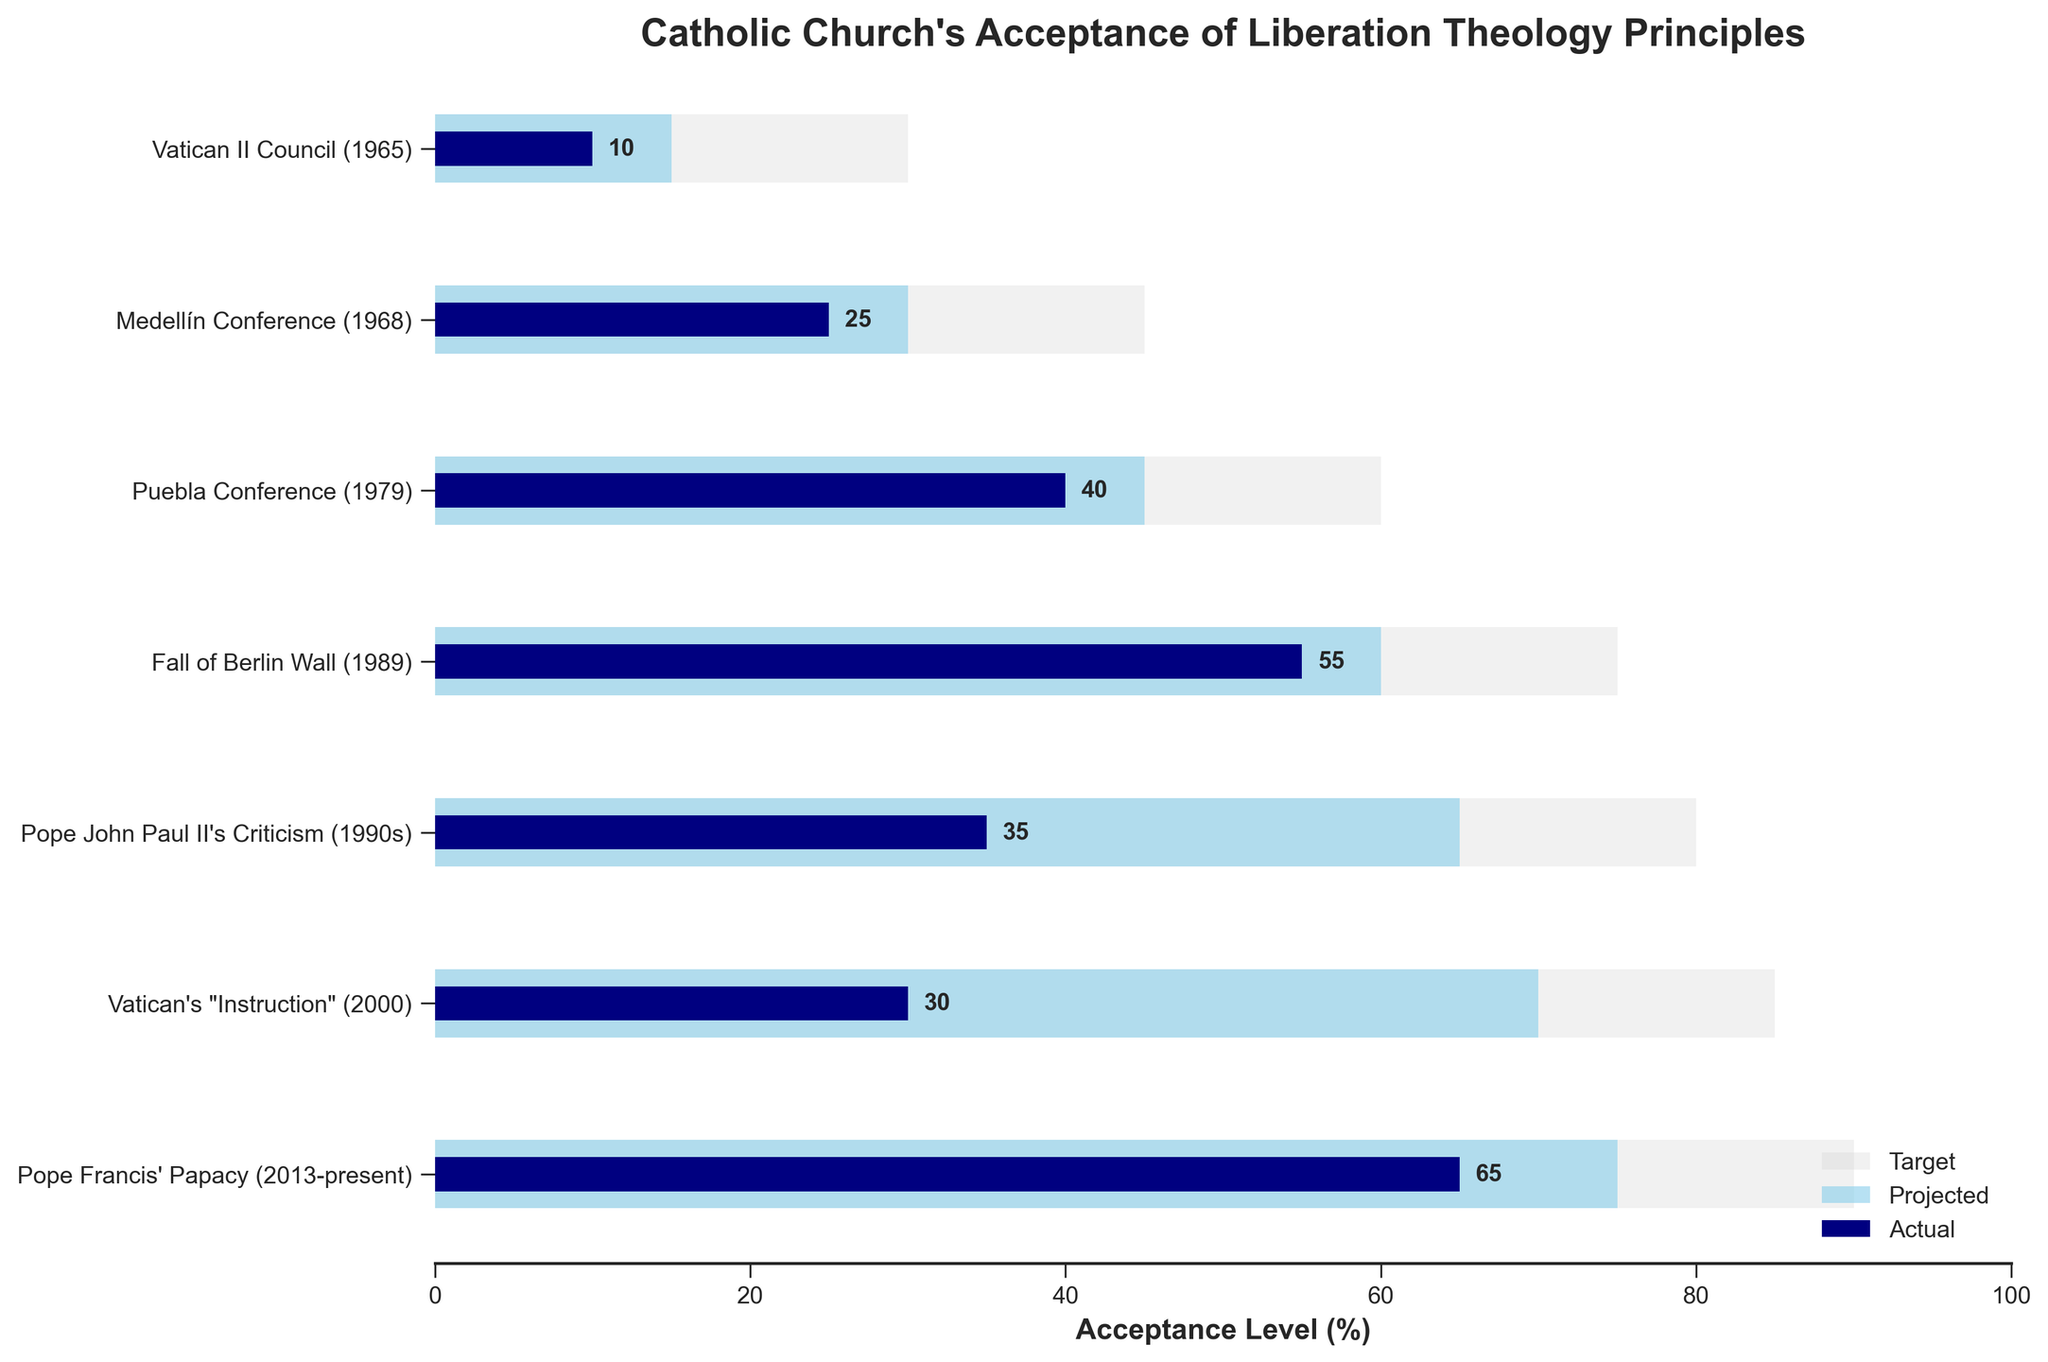What is the title of the chart? The title can be seen at the top of the figure. It is "Catholic Church's Acceptance of Liberation Theology Principles".
Answer: Catholic Church's Acceptance of Liberation Theology Principles How many data points are represented in the figure? By counting the categories on the y-axis, we can see there are 7 data points.
Answer: 7 Which historical event shows the highest actual acceptance of liberation theology principles? By looking at the actual acceptance bars, the longest is for "Pope Francis' Papacy (2013-present)" with a value of 65.
Answer: Pope Francis' Papacy (2013-present) What is the difference between the projected and actual acceptance levels for Pope Francis' Papacy? The projected acceptance for Pope Francis' Papacy is 75 and the actual acceptance is 65. The difference is 75 - 65.
Answer: 10 At which historical point did the actual acceptance level decrease following an initial increase? Observing the trends, the actual acceptance levels rise from "Vatican II Council" to "Fall of Berlin Wall", but then decrease at "Pope John Paul II's Criticism" and "Vatican's Instruction".
Answer: Pope John Paul II's Criticism What is the target acceptance level during the Vatican II Council (1965)? Looking at the target bar corresponding to "Vatican II Council (1965)", it reaches up to 30.
Answer: 30 Which historical event had the smallest gap between projected and actual acceptance levels? By calculating the difference for each event: 
- Vatican II Council: 15 - 10 = 5
- Medellín Conference: 30 - 25 = 5
- Puebla Conference: 45 - 40 = 5
- Fall of Berlin Wall: 60 - 55 = 5
- Pope John Paul II's Criticism: 65 - 35 = 30
- Vatican's Instruction: 70 - 30 = 40
- Pope Francis' Papacy: 75 - 65 = 10
The smallest differences are all 5.
Answer: Vatican II Council, Medellín Conference, Puebla Conference, Fall of Berlin Wall What is the average actual acceptance level across all historical events? Sum the actual acceptance levels: 10 + 25 + 40 + 55 + 35 + 30 + 65 = 260. The total number of events is 7. The average is 260 / 7.
Answer: 37.14 Which event has the highest projected acceptance level? By comparing the projected acceptance levels, the highest is for "Vatican's Instruction (2000)" with a value of 70.
Answer: Vatican's "Instruction" How does the actual acceptance during "Vatican's Instruction" compare to the target and projected levels? For "Vatican's Instruction":
- Actual: 30
- Projected: 70
- Target: 85
The actual level is lower than both the projected and target levels.
Answer: Lower than both 